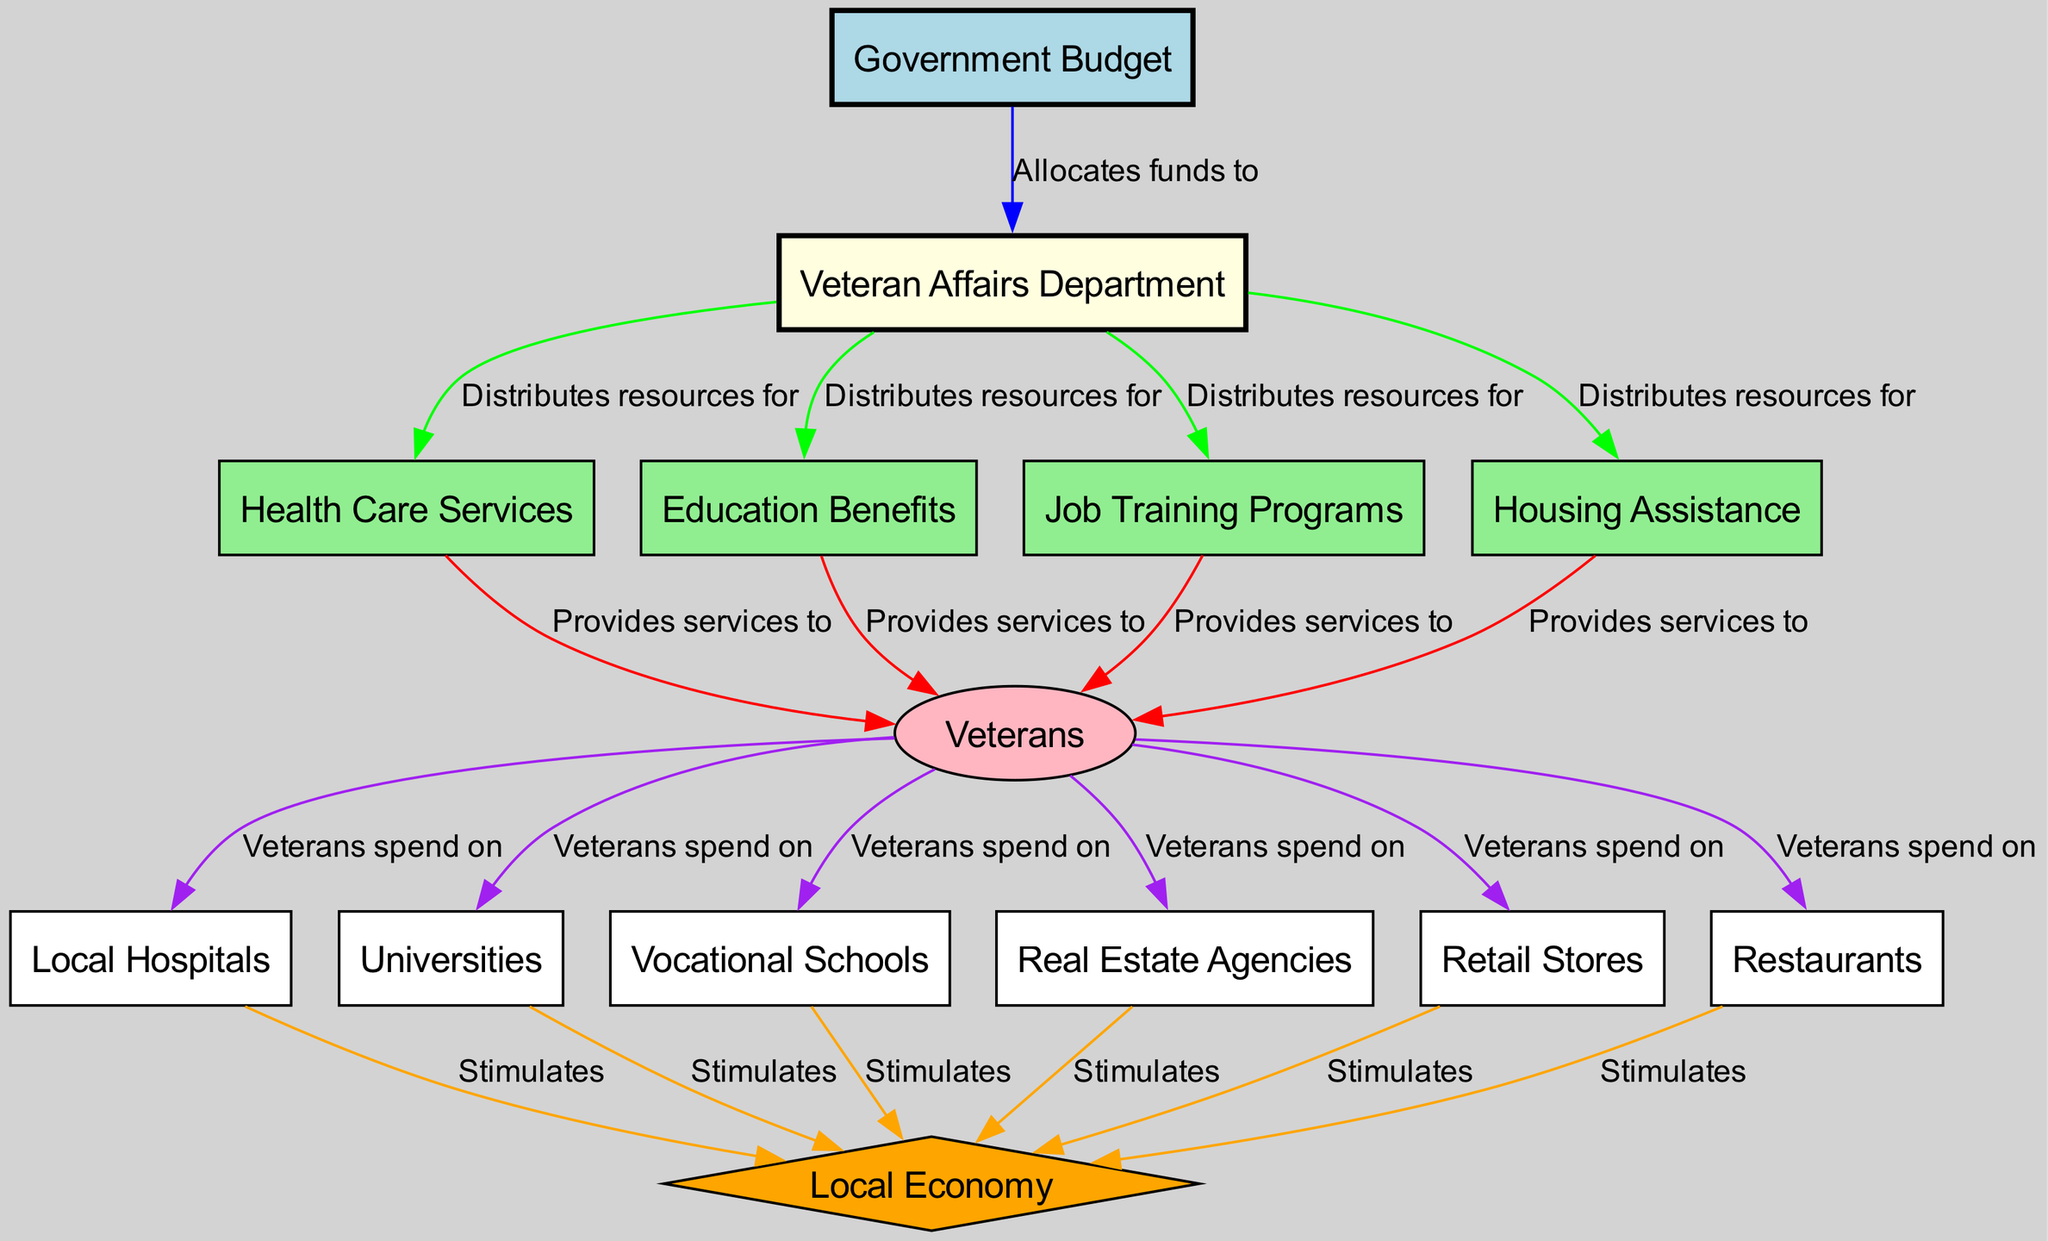What is the starting point of fund allocation in this flow chart? The flow chart starts with the "Government Budget," which allocates funds to the "Veteran Affairs Department." This is the first node that shows where the flow of funds begins, indicating its crucial role in initiating the process.
Answer: Government Budget How many entities are funded by the Veteran Affairs Department? The Veteran Affairs Department distributes resources for four entities: Health Care Services, Education Benefits, Job Training Programs, and Housing Assistance. Each of these entities is visually connected to the Veteran Affairs Department through edges labeled "Distributes resources for."
Answer: Four Which node represents the ultimate economic impact of veteran spending? The "Local Economy" node represents the ultimate economic impact. It is the final node where funds flow to and is stimulated by various businesses that veterans spend their money on.
Answer: Local Economy What services are provided to veterans according to the diagram? The services provided to veterans, as indicated by the edges labeled "Provides services to," include Health Care Services, Education Benefits, Job Training Programs, and Housing Assistance. These are linked directly to the Veterans node.
Answer: Health Care Services, Education Benefits, Job Training Programs, Housing Assistance Which businesses benefit directly from veteran spending? The businesses that benefit directly from veteran spending include Local Hospitals, Universities, Vocational Schools, Real Estate Agencies, Retail Stores, and Restaurants. Each of these nodes receives spending from Veterans, creating a direct economic link.
Answer: Local Hospitals, Universities, Vocational Schools, Real Estate Agencies, Retail Stores, Restaurants What color represents nodes that distribute resources for veterans? The nodes that distribute resources for veterans, such as Health Care Services, Education Benefits, Job Training Programs, and Housing Assistance, are filled with light green color. This color-coding helps to visually distinguish their role in the flow chart.
Answer: Light green How do veteran expenditures affect the local economy? Veteran expenditures stimulate the local economy, as shown by the edges leading from Local Hospitals, Universities, Vocational Schools, Real Estate Agencies, Retail Stores, and Restaurants to the Local Economy node. Each business node contributes to economic stimulation when benefits are spent.
Answer: Stimulates Which department allocates funds from the government budget? The "Veteran Affairs Department" is the department that receives the allocation of funds from the Government Budget. It serves as the intermediary that manages the funds before distributing them to various services.
Answer: Veteran Affairs Department How many distinct paths flow from veterans to the local economy? There are six distinct paths that flow from veterans to the local economy, as indicated by the connections from Veterans to each of the six business nodes. Each path illustrates a unique avenue through which spending impacts the local economy.
Answer: Six 